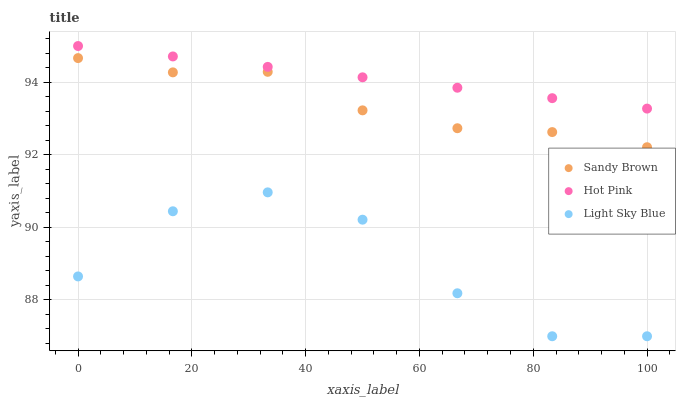Does Light Sky Blue have the minimum area under the curve?
Answer yes or no. Yes. Does Hot Pink have the maximum area under the curve?
Answer yes or no. Yes. Does Sandy Brown have the minimum area under the curve?
Answer yes or no. No. Does Sandy Brown have the maximum area under the curve?
Answer yes or no. No. Is Hot Pink the smoothest?
Answer yes or no. Yes. Is Light Sky Blue the roughest?
Answer yes or no. Yes. Is Sandy Brown the smoothest?
Answer yes or no. No. Is Sandy Brown the roughest?
Answer yes or no. No. Does Light Sky Blue have the lowest value?
Answer yes or no. Yes. Does Sandy Brown have the lowest value?
Answer yes or no. No. Does Hot Pink have the highest value?
Answer yes or no. Yes. Does Sandy Brown have the highest value?
Answer yes or no. No. Is Light Sky Blue less than Sandy Brown?
Answer yes or no. Yes. Is Hot Pink greater than Sandy Brown?
Answer yes or no. Yes. Does Light Sky Blue intersect Sandy Brown?
Answer yes or no. No. 